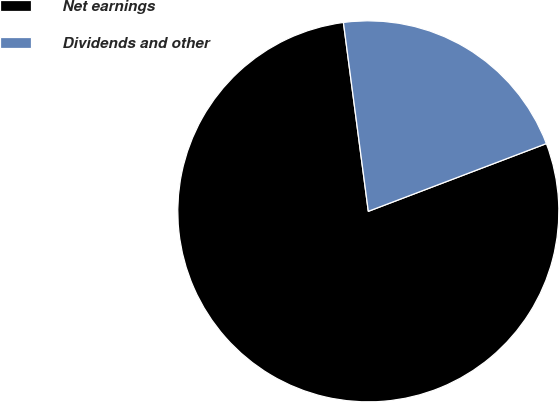Convert chart to OTSL. <chart><loc_0><loc_0><loc_500><loc_500><pie_chart><fcel>Net earnings<fcel>Dividends and other<nl><fcel>78.7%<fcel>21.3%<nl></chart> 